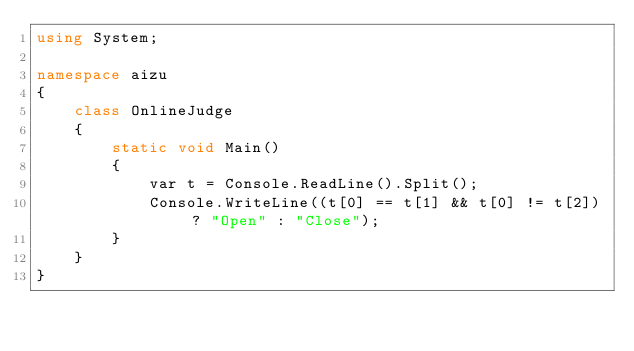Convert code to text. <code><loc_0><loc_0><loc_500><loc_500><_C#_>using System;

namespace aizu
{
    class OnlineJudge
    {
        static void Main()
        {
            var t = Console.ReadLine().Split();
            Console.WriteLine((t[0] == t[1] && t[0] != t[2]) ? "Open" : "Close");
        }
    }
}</code> 